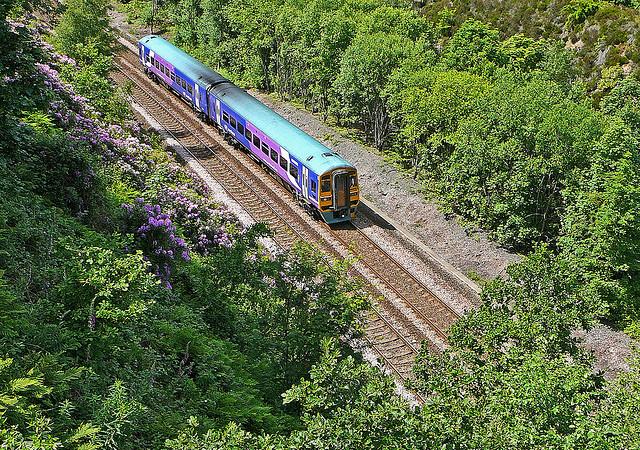Are there any blooming plants beside the rail tracks?
Quick response, please. Yes. Is this train blue?
Answer briefly. Yes. Is the train driving through a metropolitan city?
Write a very short answer. No. What color is the train?
Quick response, please. Blue. 